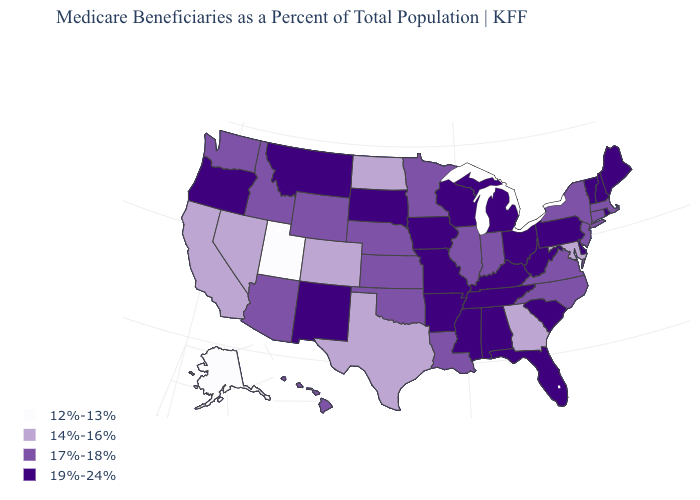What is the value of New Jersey?
Keep it brief. 17%-18%. Name the states that have a value in the range 14%-16%?
Quick response, please. California, Colorado, Georgia, Maryland, Nevada, North Dakota, Texas. Which states have the highest value in the USA?
Be succinct. Alabama, Arkansas, Delaware, Florida, Iowa, Kentucky, Maine, Michigan, Mississippi, Missouri, Montana, New Hampshire, New Mexico, Ohio, Oregon, Pennsylvania, Rhode Island, South Carolina, South Dakota, Tennessee, Vermont, West Virginia, Wisconsin. Which states hav the highest value in the MidWest?
Write a very short answer. Iowa, Michigan, Missouri, Ohio, South Dakota, Wisconsin. Among the states that border Illinois , which have the lowest value?
Answer briefly. Indiana. Name the states that have a value in the range 14%-16%?
Quick response, please. California, Colorado, Georgia, Maryland, Nevada, North Dakota, Texas. Does the map have missing data?
Quick response, please. No. What is the highest value in states that border Montana?
Short answer required. 19%-24%. What is the value of Michigan?
Give a very brief answer. 19%-24%. What is the value of Wyoming?
Be succinct. 17%-18%. Is the legend a continuous bar?
Be succinct. No. Name the states that have a value in the range 17%-18%?
Short answer required. Arizona, Connecticut, Hawaii, Idaho, Illinois, Indiana, Kansas, Louisiana, Massachusetts, Minnesota, Nebraska, New Jersey, New York, North Carolina, Oklahoma, Virginia, Washington, Wyoming. What is the lowest value in the MidWest?
Keep it brief. 14%-16%. Among the states that border South Dakota , which have the highest value?
Keep it brief. Iowa, Montana. What is the highest value in the USA?
Keep it brief. 19%-24%. 